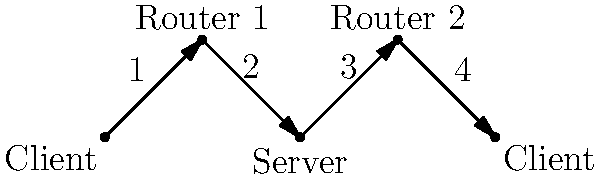In the given network diagram, a packet is sent from the leftmost client to the rightmost client. How many routers does the packet pass through during its journey? To determine the number of routers the packet passes through, we need to trace its path from the source (leftmost client) to the destination (rightmost client):

1. The packet starts at the leftmost client.
2. It first travels to Router 1 (edge 1).
3. From Router 1, it goes to the Server (edge 2).
4. The Server then sends it to Router 2 (edge 3).
5. Finally, Router 2 forwards it to the rightmost client (edge 4).

Counting the routers in this path:
- Router 1
- Router 2

Therefore, the packet passes through 2 routers during its journey from the leftmost client to the rightmost client.
Answer: 2 